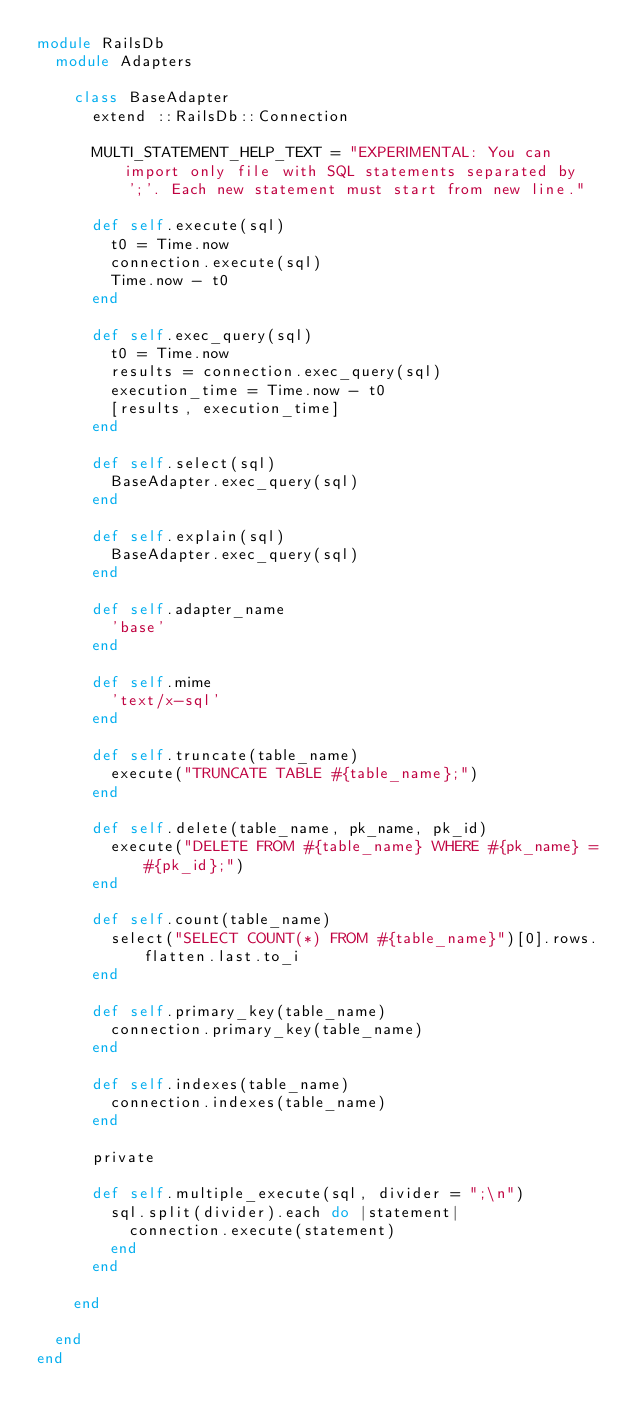<code> <loc_0><loc_0><loc_500><loc_500><_Ruby_>module RailsDb
  module Adapters

    class BaseAdapter
      extend ::RailsDb::Connection

      MULTI_STATEMENT_HELP_TEXT = "EXPERIMENTAL: You can import only file with SQL statements separated by ';'. Each new statement must start from new line."

      def self.execute(sql)
        t0 = Time.now
        connection.execute(sql)
        Time.now - t0
      end

      def self.exec_query(sql)
        t0 = Time.now
        results = connection.exec_query(sql)
        execution_time = Time.now - t0
        [results, execution_time]
      end

      def self.select(sql)
        BaseAdapter.exec_query(sql)
      end

      def self.explain(sql)
        BaseAdapter.exec_query(sql)
      end

      def self.adapter_name
        'base'
      end

      def self.mime
        'text/x-sql'
      end

      def self.truncate(table_name)
        execute("TRUNCATE TABLE #{table_name};")
      end

      def self.delete(table_name, pk_name, pk_id)
        execute("DELETE FROM #{table_name} WHERE #{pk_name} = #{pk_id};")
      end

      def self.count(table_name)
        select("SELECT COUNT(*) FROM #{table_name}")[0].rows.flatten.last.to_i
      end

      def self.primary_key(table_name)
        connection.primary_key(table_name)
      end

      def self.indexes(table_name)
        connection.indexes(table_name)
      end

      private

      def self.multiple_execute(sql, divider = ";\n")
        sql.split(divider).each do |statement|
          connection.execute(statement)
        end
      end

    end

  end
end</code> 